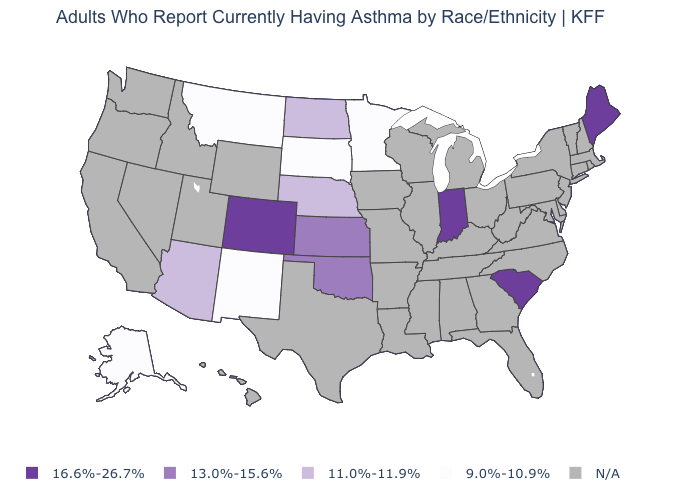Name the states that have a value in the range N/A?
Answer briefly. Alabama, Arkansas, California, Connecticut, Delaware, Florida, Georgia, Hawaii, Idaho, Illinois, Iowa, Kentucky, Louisiana, Maryland, Massachusetts, Michigan, Mississippi, Missouri, Nevada, New Hampshire, New Jersey, New York, North Carolina, Ohio, Oregon, Pennsylvania, Rhode Island, Tennessee, Texas, Utah, Vermont, Virginia, Washington, West Virginia, Wisconsin, Wyoming. What is the value of Maine?
Give a very brief answer. 16.6%-26.7%. Which states have the lowest value in the MidWest?
Be succinct. Minnesota, South Dakota. What is the lowest value in the USA?
Concise answer only. 9.0%-10.9%. Does the map have missing data?
Quick response, please. Yes. What is the lowest value in the USA?
Answer briefly. 9.0%-10.9%. Among the states that border Idaho , which have the lowest value?
Give a very brief answer. Montana. What is the highest value in the USA?
Write a very short answer. 16.6%-26.7%. Among the states that border Texas , does New Mexico have the highest value?
Be succinct. No. Which states have the lowest value in the MidWest?
Short answer required. Minnesota, South Dakota. Which states have the lowest value in the USA?
Be succinct. Alaska, Minnesota, Montana, New Mexico, South Dakota. 